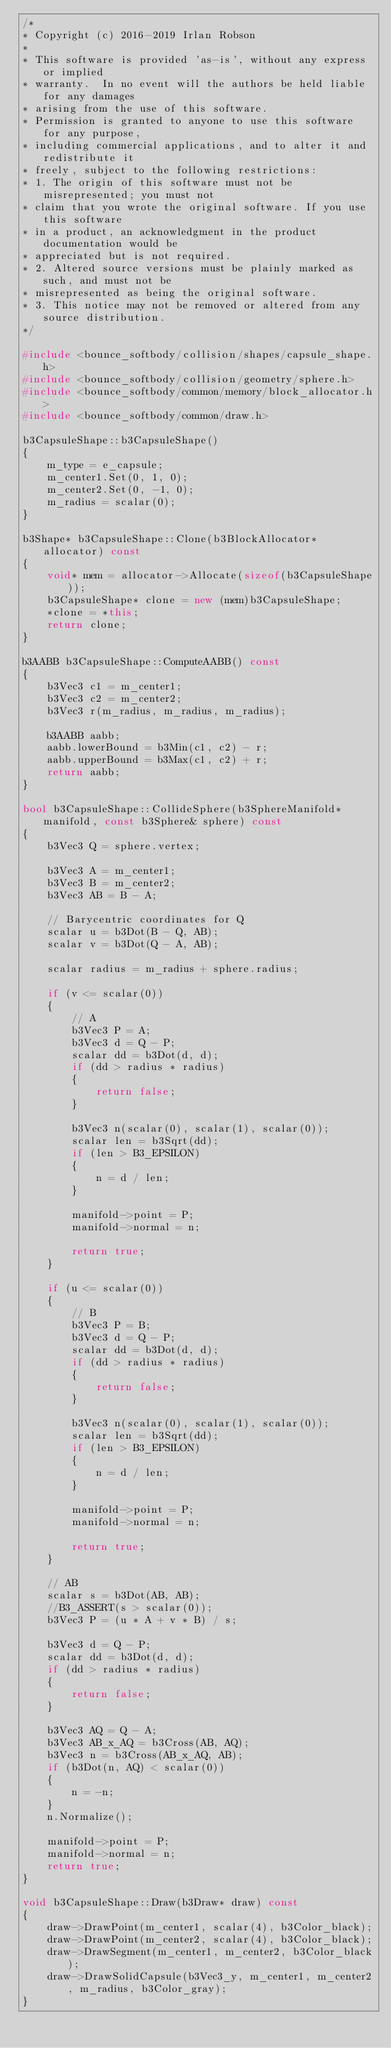Convert code to text. <code><loc_0><loc_0><loc_500><loc_500><_C++_>/*
* Copyright (c) 2016-2019 Irlan Robson
*
* This software is provided 'as-is', without any express or implied
* warranty.  In no event will the authors be held liable for any damages
* arising from the use of this software.
* Permission is granted to anyone to use this software for any purpose,
* including commercial applications, and to alter it and redistribute it
* freely, subject to the following restrictions:
* 1. The origin of this software must not be misrepresented; you must not
* claim that you wrote the original software. If you use this software
* in a product, an acknowledgment in the product documentation would be
* appreciated but is not required.
* 2. Altered source versions must be plainly marked as such, and must not be
* misrepresented as being the original software.
* 3. This notice may not be removed or altered from any source distribution.
*/

#include <bounce_softbody/collision/shapes/capsule_shape.h>
#include <bounce_softbody/collision/geometry/sphere.h>
#include <bounce_softbody/common/memory/block_allocator.h>
#include <bounce_softbody/common/draw.h>

b3CapsuleShape::b3CapsuleShape()
{
	m_type = e_capsule;
	m_center1.Set(0, 1, 0);
	m_center2.Set(0, -1, 0);
	m_radius = scalar(0);
}

b3Shape* b3CapsuleShape::Clone(b3BlockAllocator* allocator) const
{
	void* mem = allocator->Allocate(sizeof(b3CapsuleShape));
	b3CapsuleShape* clone = new (mem)b3CapsuleShape;
	*clone = *this;
	return clone;
}

b3AABB b3CapsuleShape::ComputeAABB() const
{
	b3Vec3 c1 = m_center1;
	b3Vec3 c2 = m_center2;
	b3Vec3 r(m_radius, m_radius, m_radius);
	
	b3AABB aabb;
	aabb.lowerBound = b3Min(c1, c2) - r;
	aabb.upperBound = b3Max(c1, c2) + r;
	return aabb;
}

bool b3CapsuleShape::CollideSphere(b3SphereManifold* manifold, const b3Sphere& sphere) const
{
	b3Vec3 Q = sphere.vertex;

	b3Vec3 A = m_center1;
	b3Vec3 B = m_center2;
	b3Vec3 AB = B - A;

	// Barycentric coordinates for Q
	scalar u = b3Dot(B - Q, AB);
	scalar v = b3Dot(Q - A, AB);

	scalar radius = m_radius + sphere.radius;

	if (v <= scalar(0))
	{
		// A
		b3Vec3 P = A;
		b3Vec3 d = Q - P;
		scalar dd = b3Dot(d, d);
		if (dd > radius * radius)
		{
			return false;
		}

		b3Vec3 n(scalar(0), scalar(1), scalar(0));
		scalar len = b3Sqrt(dd);
		if (len > B3_EPSILON)
		{
			n = d / len;
		}

		manifold->point = P;
		manifold->normal = n;

		return true;
	}

	if (u <= scalar(0))
	{
		// B
		b3Vec3 P = B;
		b3Vec3 d = Q - P;
		scalar dd = b3Dot(d, d);
		if (dd > radius * radius)
		{
			return false;
		}

		b3Vec3 n(scalar(0), scalar(1), scalar(0));
		scalar len = b3Sqrt(dd);
		if (len > B3_EPSILON)
		{
			n = d / len;
		}

		manifold->point = P;
		manifold->normal = n;

		return true;
	}

	// AB
	scalar s = b3Dot(AB, AB);
	//B3_ASSERT(s > scalar(0));
	b3Vec3 P = (u * A + v * B) / s;

	b3Vec3 d = Q - P;
	scalar dd = b3Dot(d, d);
	if (dd > radius * radius)
	{
		return false;
	}

	b3Vec3 AQ = Q - A;
	b3Vec3 AB_x_AQ = b3Cross(AB, AQ);
	b3Vec3 n = b3Cross(AB_x_AQ, AB);
	if (b3Dot(n, AQ) < scalar(0))
	{
		n = -n;
	}
	n.Normalize();

	manifold->point = P;
	manifold->normal = n;
	return true;
}

void b3CapsuleShape::Draw(b3Draw* draw) const
{
	draw->DrawPoint(m_center1, scalar(4), b3Color_black);
	draw->DrawPoint(m_center2, scalar(4), b3Color_black);
	draw->DrawSegment(m_center1, m_center2, b3Color_black);
	draw->DrawSolidCapsule(b3Vec3_y, m_center1, m_center2, m_radius, b3Color_gray);
}</code> 